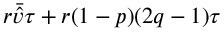<formula> <loc_0><loc_0><loc_500><loc_500>r \bar { \hat { v } } \tau + r ( 1 - p ) ( 2 q - 1 ) \tau</formula> 